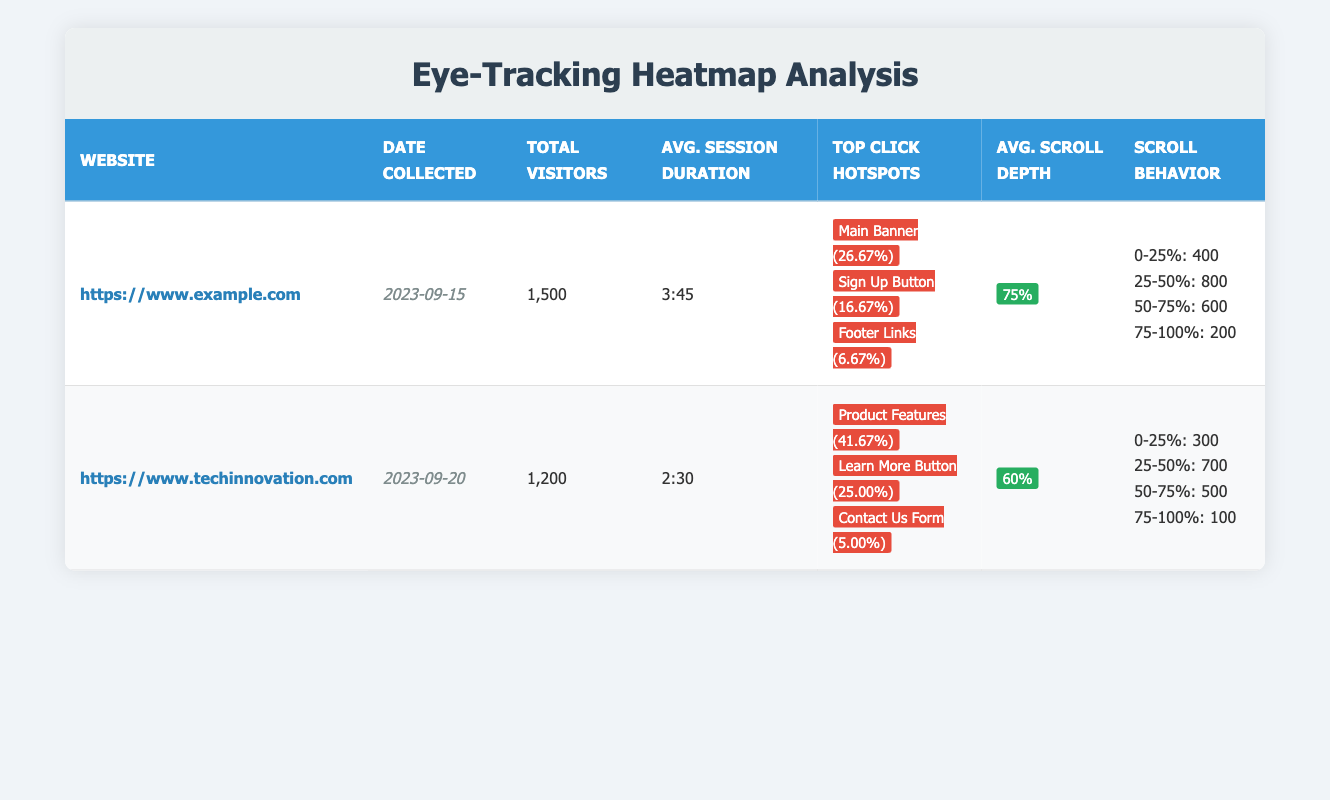What is the total number of visitors for the website example.com? The table shows the row for the website https://www.example.com, which lists the total visitors as 1,500.
Answer: 1,500 What is the average session duration for techinnovation.com? In the table, the average session duration for https://www.techinnovation.com is listed as 2:30.
Answer: 2:30 Which element on example.com received the highest conversion rate? The table specifies that the Main Banner on https://www.example.com has the highest conversion rate at 26.67%.
Answer: Main Banner What is the total number of clicks for all hotspots on techinnovation.com? To find the total clicks, sum the clicks for each hotspot: 300 (Learn More Button) + 500 (Product Features Section) + 60 (Contact Us Form) = 860.
Answer: 860 Is the average scroll depth for example.com greater than that of techinnovation.com? The average scroll depth for example.com is 75%, while for techinnovation.com it is 60%. Since 75% is greater than 60%, the statement is true.
Answer: Yes What percentage of visitors reached the scroll depth of 0-25% on the example.com website? The 0-25% scroll depth had 400 participants. To find the percentage, divide 400 by the total visitors (1500) and multiply by 100: (400/1500) * 100 = 26.67%.
Answer: 26.67% Which hotspot on techinnovation.com has the lowest conversion rate? In the table, the Contact Us Form has the lowest conversion rate at 5.00%.
Answer: Contact Us Form How many participants were recorded at the 75-100% scroll depth for techinnovation.com? By checking the scrolling behavior for https://www.techinnovation.com, it indicates 100 participants were recorded at the scroll depth of 75-100%.
Answer: 100 What is the average session duration difference between example.com and techinnovation.com? The session duration for example.com is 3:45 (which converts to 225 seconds) and for techinnovation.com it is 2:30 (which converts to 150 seconds). The difference is 225 - 150 = 75 seconds.
Answer: 75 seconds 